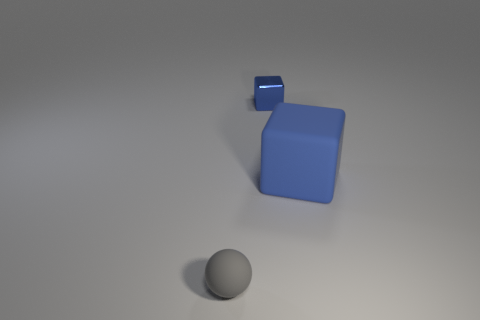Are there any blue cubes behind the sphere to the left of the tiny thing that is behind the blue rubber thing?
Your answer should be very brief. Yes. Are the big blue object and the tiny thing that is in front of the big matte block made of the same material?
Your answer should be compact. Yes. There is a matte thing left of the blue cube that is on the left side of the blue rubber object; what color is it?
Keep it short and to the point. Gray. Is there a tiny metal block of the same color as the big rubber object?
Ensure brevity in your answer.  Yes. There is a matte thing that is on the left side of the block that is in front of the tiny thing that is right of the tiny ball; what is its size?
Your response must be concise. Small. There is a gray rubber object; does it have the same shape as the thing that is behind the big blue rubber block?
Offer a terse response. No. How many other things are the same size as the blue rubber cube?
Keep it short and to the point. 0. There is a rubber object right of the gray rubber object; what is its size?
Offer a terse response. Large. What number of blue objects are the same material as the small blue cube?
Make the answer very short. 0. There is a blue object on the right side of the shiny cube; is it the same shape as the small rubber thing?
Make the answer very short. No. 